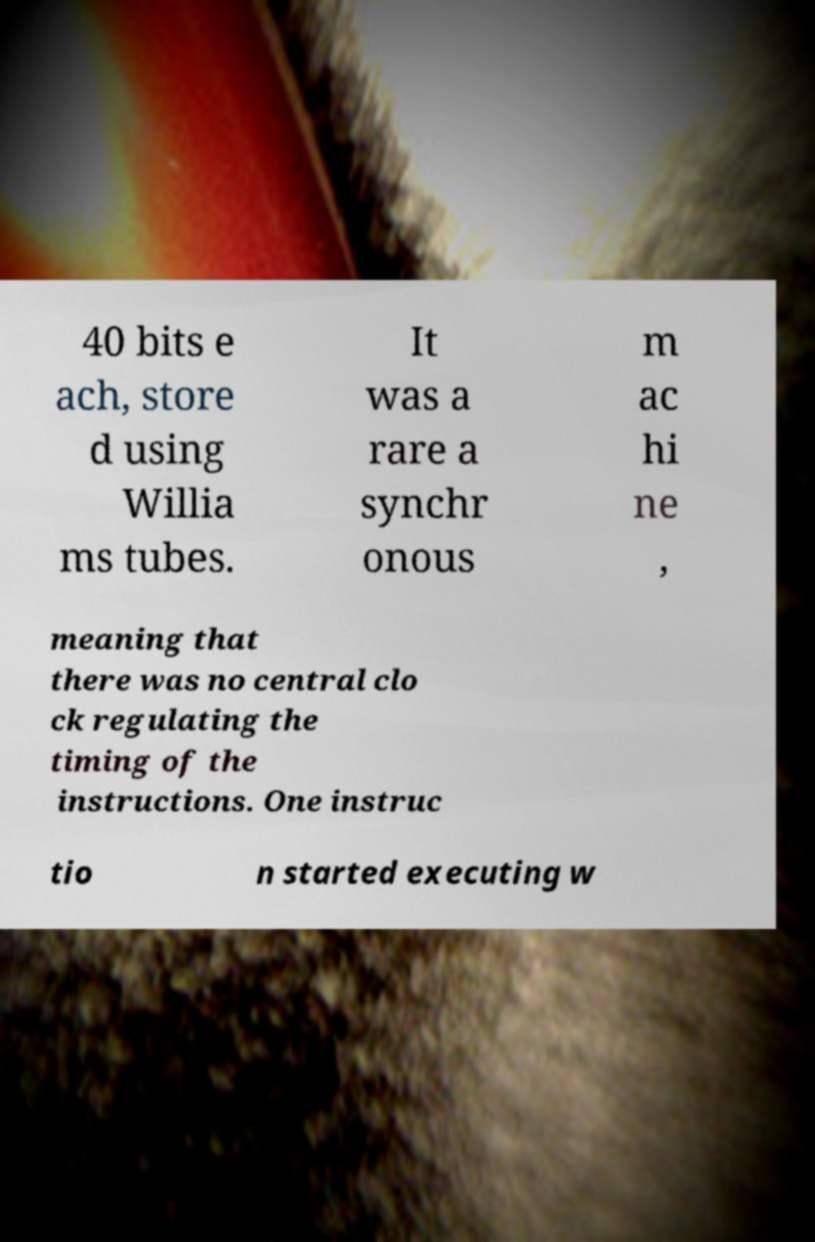There's text embedded in this image that I need extracted. Can you transcribe it verbatim? 40 bits e ach, store d using Willia ms tubes. It was a rare a synchr onous m ac hi ne , meaning that there was no central clo ck regulating the timing of the instructions. One instruc tio n started executing w 